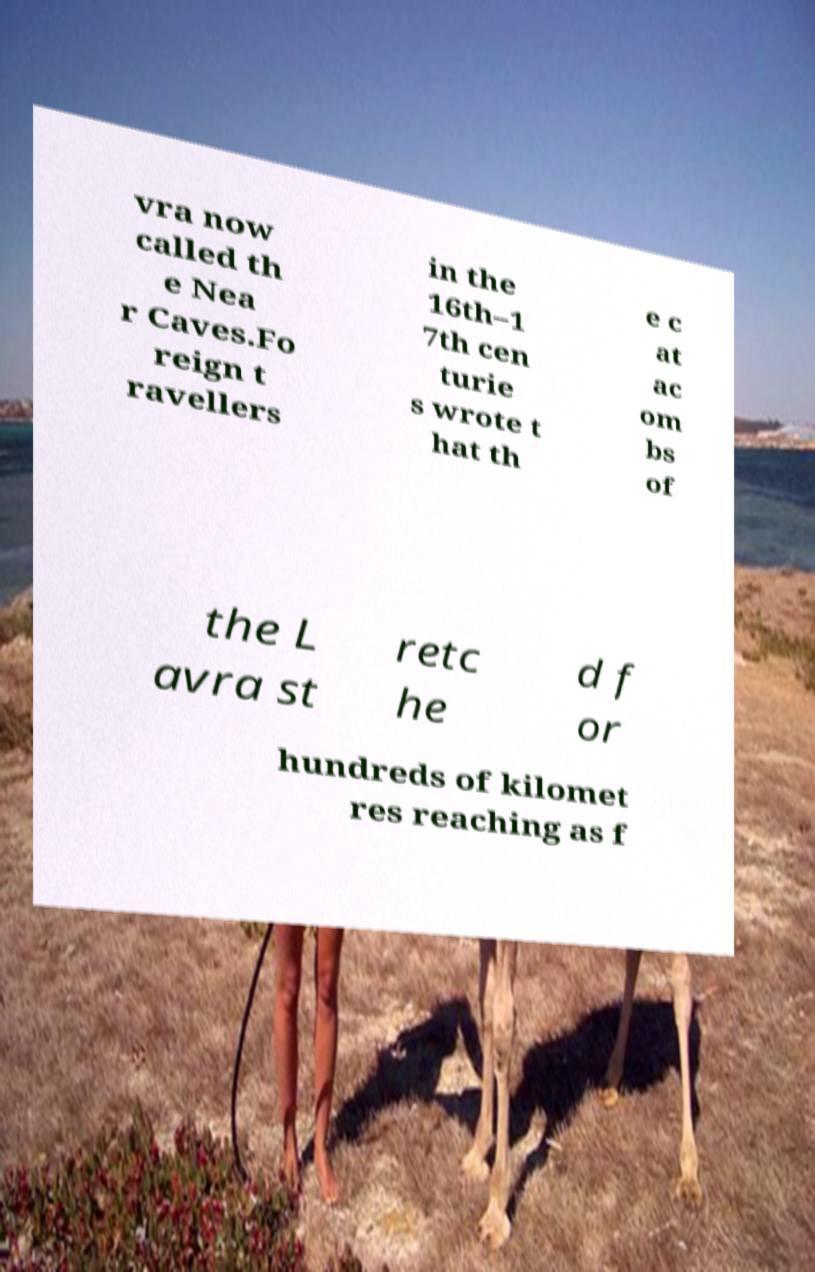There's text embedded in this image that I need extracted. Can you transcribe it verbatim? vra now called th e Nea r Caves.Fo reign t ravellers in the 16th–1 7th cen turie s wrote t hat th e c at ac om bs of the L avra st retc he d f or hundreds of kilomet res reaching as f 